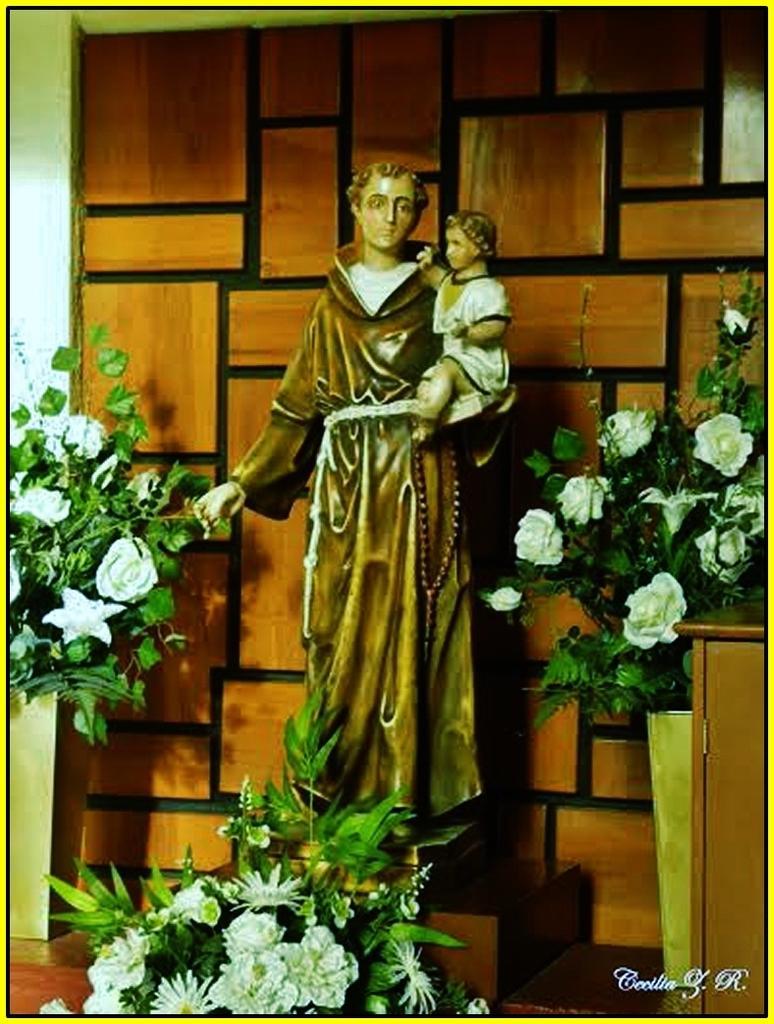Could you give a brief overview of what you see in this image? In this image I can see a statue holding a baby and there are some plants on the right side, one at the bottom ,and one on the left side. 